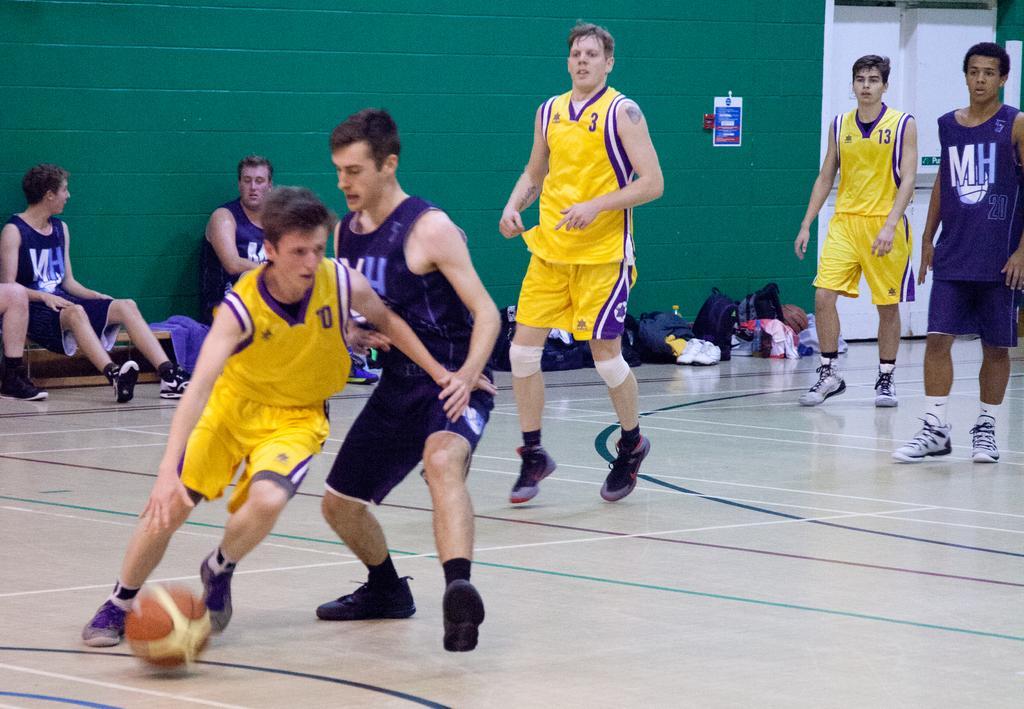In one or two sentences, can you explain what this image depicts? In the center of the image we can see people playing a game. At the bottom there is a ball. In the background we can see people sitting and there are bags placed on the floor. In the background there is a wall and a door. 